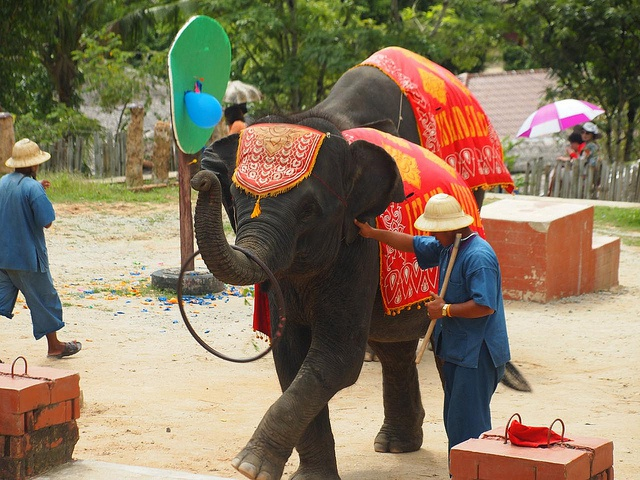Describe the objects in this image and their specific colors. I can see elephant in black, gray, and red tones, people in black, navy, blue, and maroon tones, people in black, blue, darkblue, and purple tones, umbrella in black, lavender, violet, and magenta tones, and people in black, tan, maroon, and gray tones in this image. 